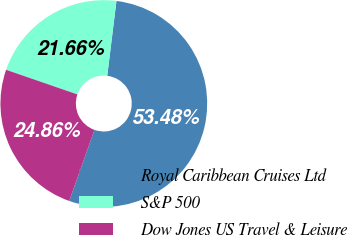<chart> <loc_0><loc_0><loc_500><loc_500><pie_chart><fcel>Royal Caribbean Cruises Ltd<fcel>S&P 500<fcel>Dow Jones US Travel & Leisure<nl><fcel>53.48%<fcel>21.66%<fcel>24.86%<nl></chart> 